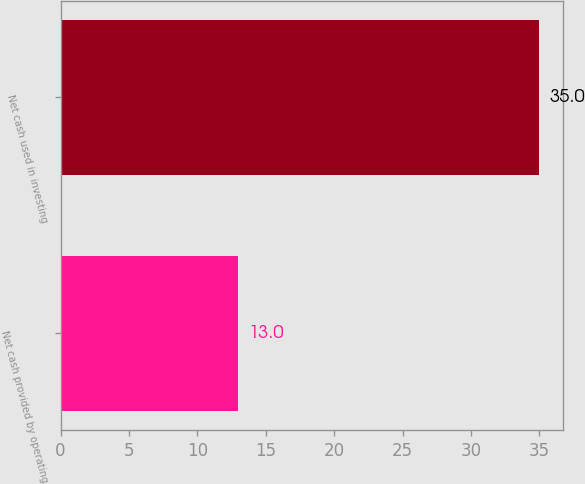<chart> <loc_0><loc_0><loc_500><loc_500><bar_chart><fcel>Net cash provided by operating<fcel>Net cash used in investing<nl><fcel>13<fcel>35<nl></chart> 